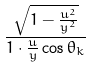Convert formula to latex. <formula><loc_0><loc_0><loc_500><loc_500>\frac { \sqrt { 1 - \frac { u ^ { 2 } } { y ^ { 2 } } } } { 1 \cdot \frac { u } { y } \cos \theta _ { k } }</formula> 